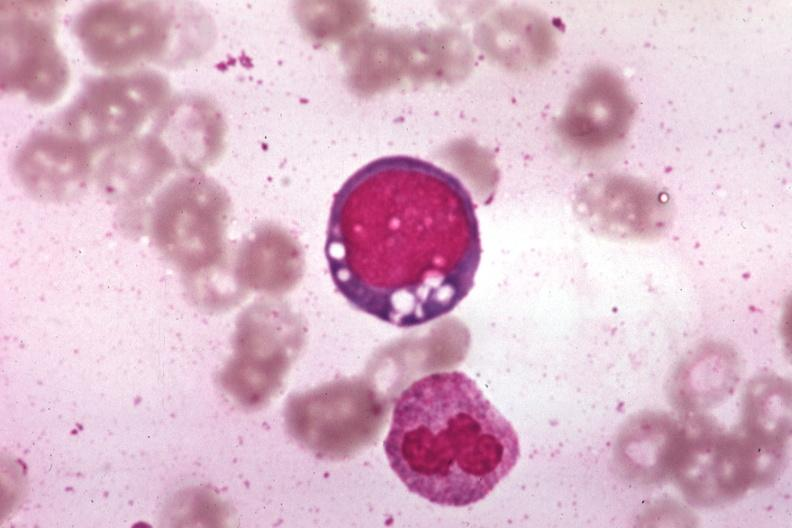what is present?
Answer the question using a single word or phrase. Hematologic 